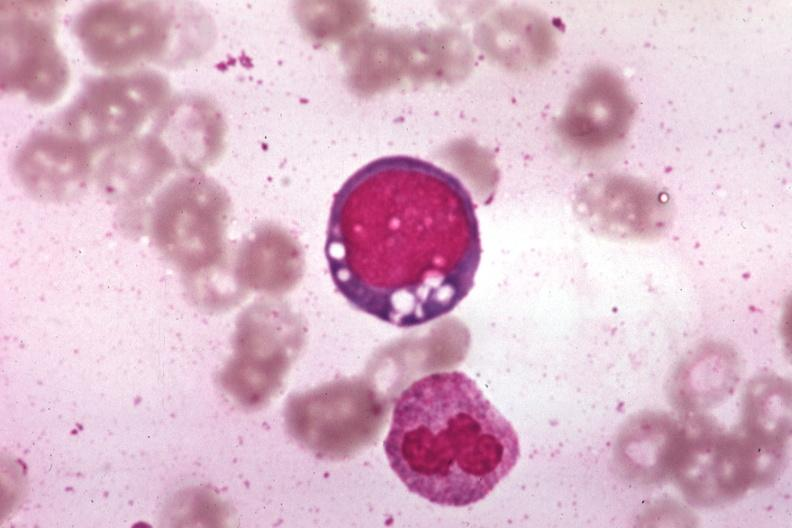what is present?
Answer the question using a single word or phrase. Hematologic 